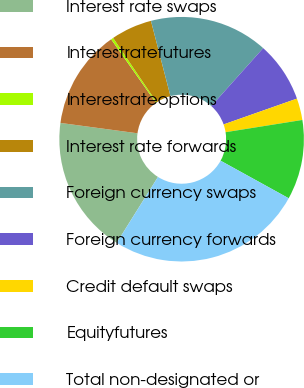Convert chart to OTSL. <chart><loc_0><loc_0><loc_500><loc_500><pie_chart><fcel>Interest rate swaps<fcel>Interestratefutures<fcel>Interestrateoptions<fcel>Interest rate forwards<fcel>Foreign currency swaps<fcel>Foreign currency forwards<fcel>Credit default swaps<fcel>Equityfutures<fcel>Total non-designated or<nl><fcel>18.22%<fcel>13.1%<fcel>0.31%<fcel>5.43%<fcel>15.66%<fcel>7.99%<fcel>2.87%<fcel>10.54%<fcel>25.89%<nl></chart> 